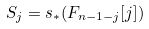<formula> <loc_0><loc_0><loc_500><loc_500>S _ { j } = s _ { * } ( F _ { n - 1 - j } [ j ] )</formula> 